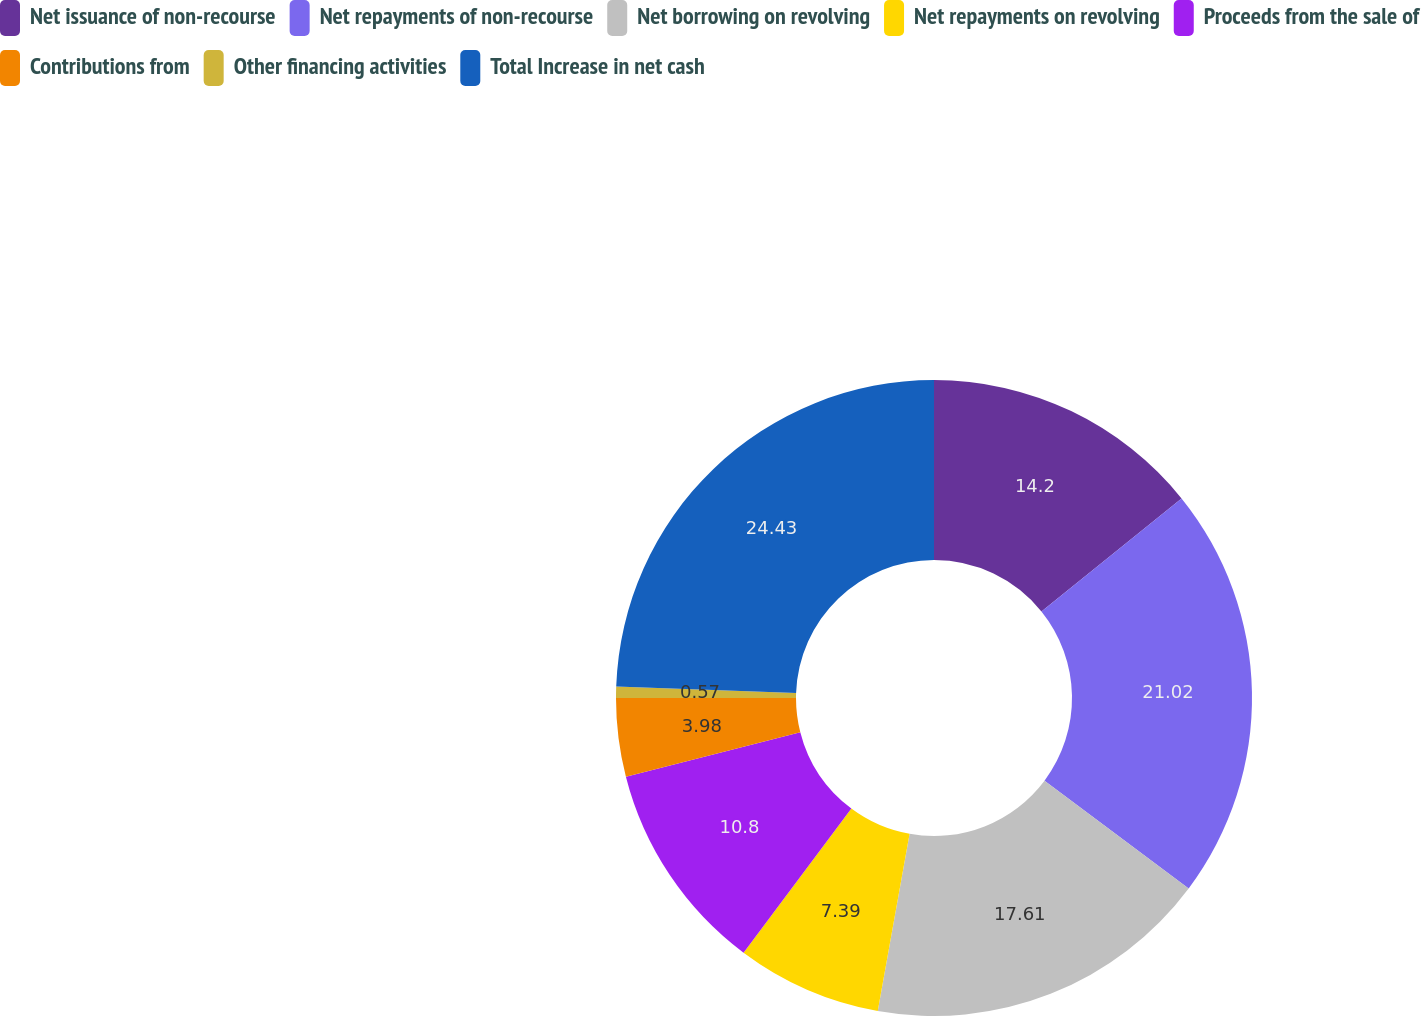<chart> <loc_0><loc_0><loc_500><loc_500><pie_chart><fcel>Net issuance of non-recourse<fcel>Net repayments of non-recourse<fcel>Net borrowing on revolving<fcel>Net repayments on revolving<fcel>Proceeds from the sale of<fcel>Contributions from<fcel>Other financing activities<fcel>Total Increase in net cash<nl><fcel>14.2%<fcel>21.02%<fcel>17.61%<fcel>7.39%<fcel>10.8%<fcel>3.98%<fcel>0.57%<fcel>24.43%<nl></chart> 